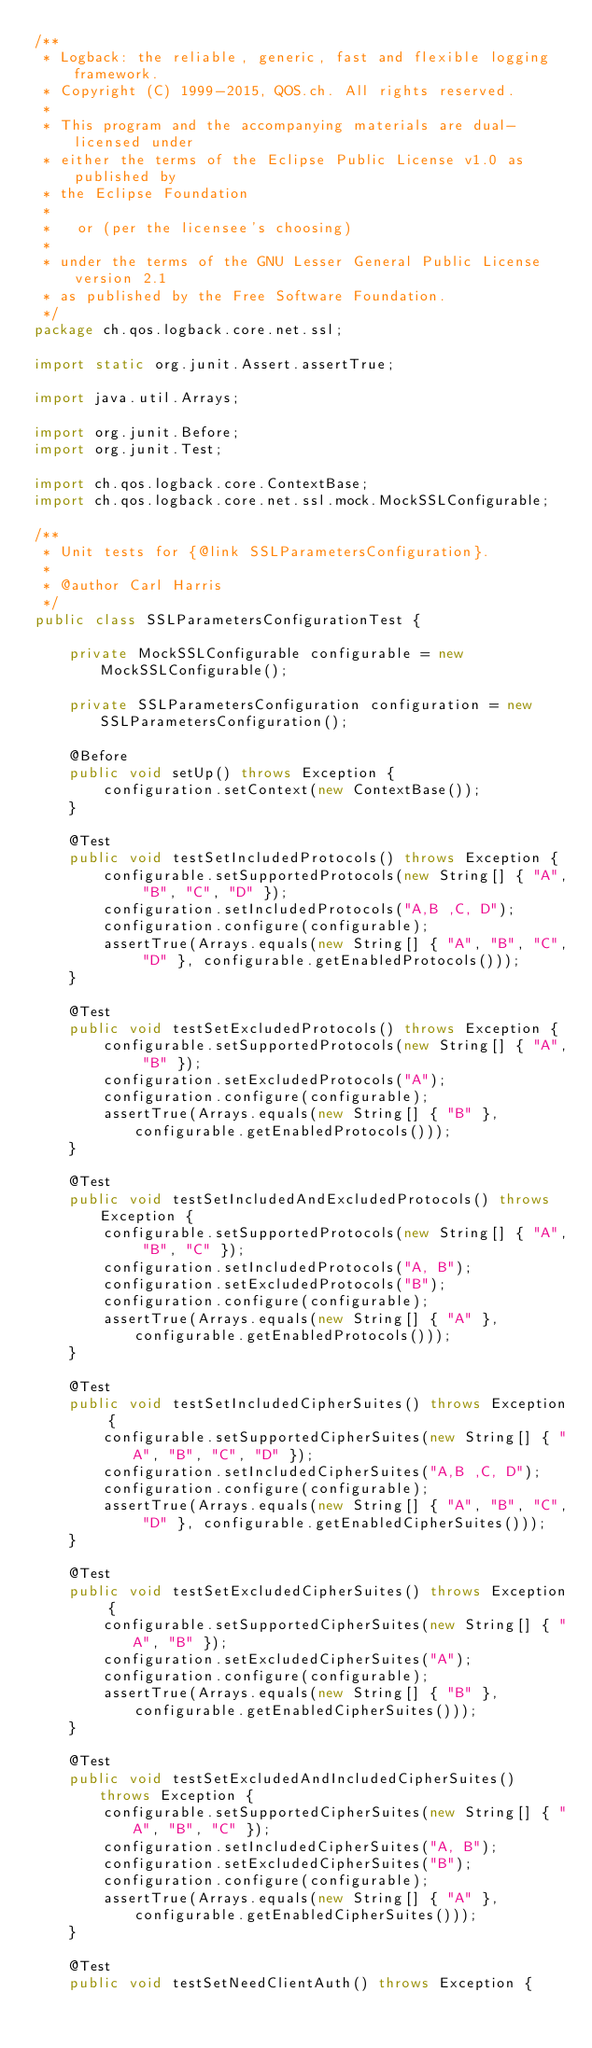Convert code to text. <code><loc_0><loc_0><loc_500><loc_500><_Java_>/**
 * Logback: the reliable, generic, fast and flexible logging framework.
 * Copyright (C) 1999-2015, QOS.ch. All rights reserved.
 *
 * This program and the accompanying materials are dual-licensed under
 * either the terms of the Eclipse Public License v1.0 as published by
 * the Eclipse Foundation
 *
 *   or (per the licensee's choosing)
 *
 * under the terms of the GNU Lesser General Public License version 2.1
 * as published by the Free Software Foundation.
 */
package ch.qos.logback.core.net.ssl;

import static org.junit.Assert.assertTrue;

import java.util.Arrays;

import org.junit.Before;
import org.junit.Test;

import ch.qos.logback.core.ContextBase;
import ch.qos.logback.core.net.ssl.mock.MockSSLConfigurable;

/**
 * Unit tests for {@link SSLParametersConfiguration}.
 *
 * @author Carl Harris
 */
public class SSLParametersConfigurationTest {

    private MockSSLConfigurable configurable = new MockSSLConfigurable();

    private SSLParametersConfiguration configuration = new SSLParametersConfiguration();

    @Before
    public void setUp() throws Exception {
        configuration.setContext(new ContextBase());
    }

    @Test
    public void testSetIncludedProtocols() throws Exception {
        configurable.setSupportedProtocols(new String[] { "A", "B", "C", "D" });
        configuration.setIncludedProtocols("A,B ,C, D");
        configuration.configure(configurable);
        assertTrue(Arrays.equals(new String[] { "A", "B", "C", "D" }, configurable.getEnabledProtocols()));
    }

    @Test
    public void testSetExcludedProtocols() throws Exception {
        configurable.setSupportedProtocols(new String[] { "A", "B" });
        configuration.setExcludedProtocols("A");
        configuration.configure(configurable);
        assertTrue(Arrays.equals(new String[] { "B" }, configurable.getEnabledProtocols()));
    }

    @Test
    public void testSetIncludedAndExcludedProtocols() throws Exception {
        configurable.setSupportedProtocols(new String[] { "A", "B", "C" });
        configuration.setIncludedProtocols("A, B");
        configuration.setExcludedProtocols("B");
        configuration.configure(configurable);
        assertTrue(Arrays.equals(new String[] { "A" }, configurable.getEnabledProtocols()));
    }

    @Test
    public void testSetIncludedCipherSuites() throws Exception {
        configurable.setSupportedCipherSuites(new String[] { "A", "B", "C", "D" });
        configuration.setIncludedCipherSuites("A,B ,C, D");
        configuration.configure(configurable);
        assertTrue(Arrays.equals(new String[] { "A", "B", "C", "D" }, configurable.getEnabledCipherSuites()));
    }

    @Test
    public void testSetExcludedCipherSuites() throws Exception {
        configurable.setSupportedCipherSuites(new String[] { "A", "B" });
        configuration.setExcludedCipherSuites("A");
        configuration.configure(configurable);
        assertTrue(Arrays.equals(new String[] { "B" }, configurable.getEnabledCipherSuites()));
    }

    @Test
    public void testSetExcludedAndIncludedCipherSuites() throws Exception {
        configurable.setSupportedCipherSuites(new String[] { "A", "B", "C" });
        configuration.setIncludedCipherSuites("A, B");
        configuration.setExcludedCipherSuites("B");
        configuration.configure(configurable);
        assertTrue(Arrays.equals(new String[] { "A" }, configurable.getEnabledCipherSuites()));
    }

    @Test
    public void testSetNeedClientAuth() throws Exception {</code> 